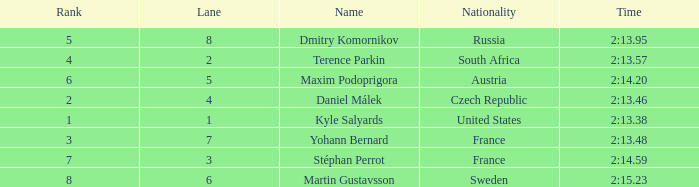What was Maxim Podoprigora's lowest rank? 6.0. 